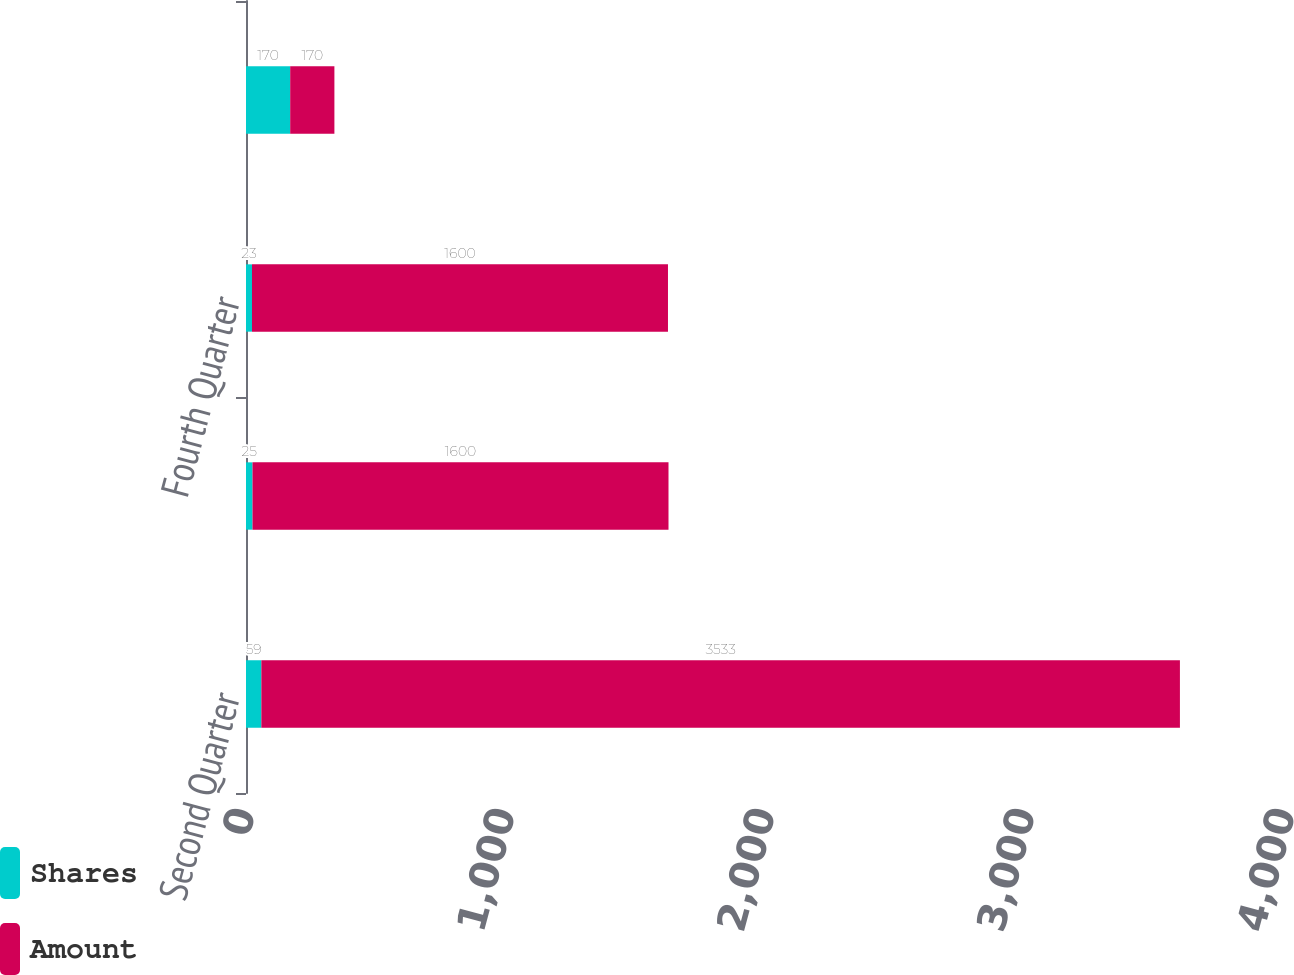Convert chart to OTSL. <chart><loc_0><loc_0><loc_500><loc_500><stacked_bar_chart><ecel><fcel>Second Quarter<fcel>Third Quarter<fcel>Fourth Quarter<fcel>Total<nl><fcel>Shares<fcel>59<fcel>25<fcel>23<fcel>170<nl><fcel>Amount<fcel>3533<fcel>1600<fcel>1600<fcel>170<nl></chart> 